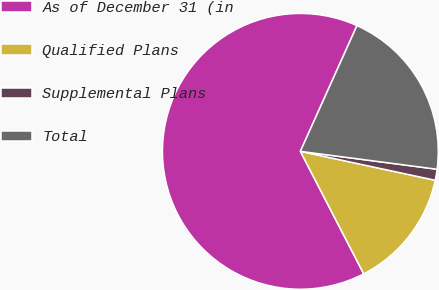Convert chart to OTSL. <chart><loc_0><loc_0><loc_500><loc_500><pie_chart><fcel>As of December 31 (in<fcel>Qualified Plans<fcel>Supplemental Plans<fcel>Total<nl><fcel>64.32%<fcel>14.04%<fcel>1.29%<fcel>20.34%<nl></chart> 